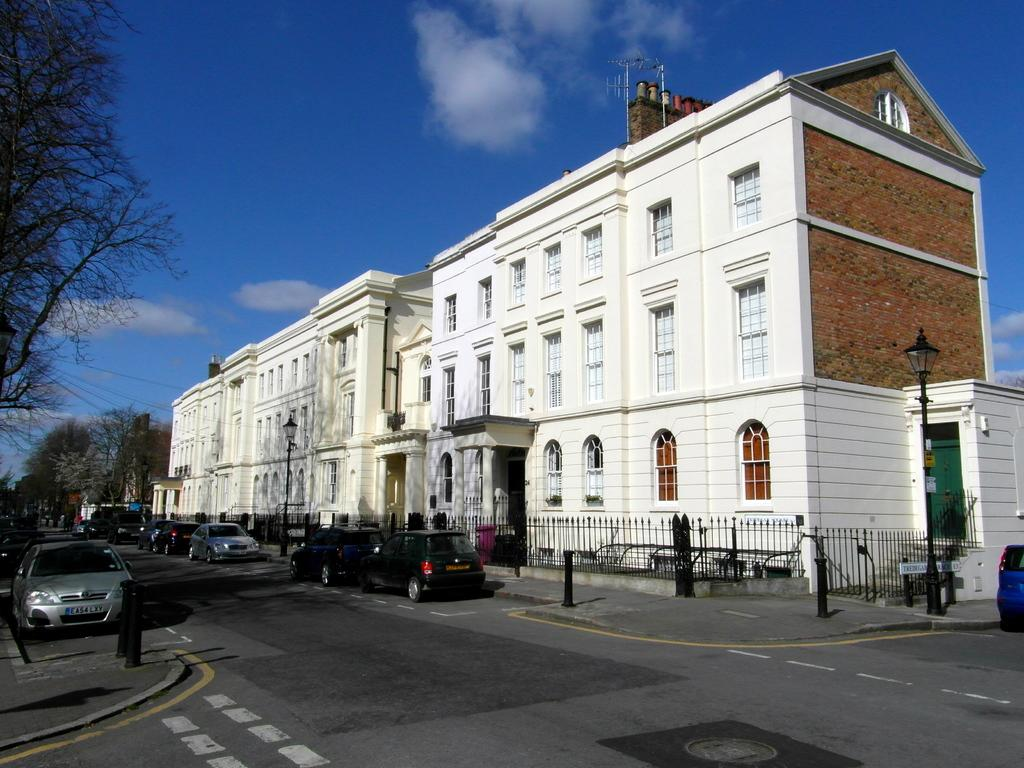What type of structure is present in the image? There is a building in the image. What is located in front of the building? A car is visible in front of the building. What separates the road from the building? There is a fence on the road. What can be seen at the top of the image? The sky is visible at the top of the image. What type of vegetation is on the left side of the image? There is a tree on the left side of the image. What kind of behavior does the aunt exhibit in the image? There is no aunt present in the image, so it is not possible to comment on her behavior. 